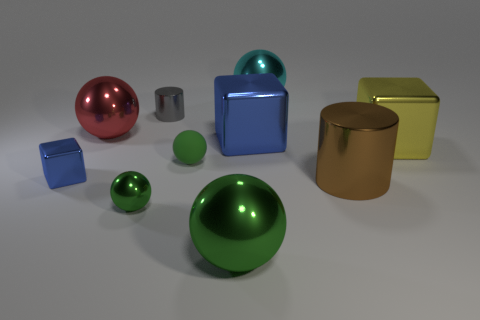How many things are either big cylinders that are right of the tiny metal block or balls?
Provide a succinct answer. 6. How many other things are the same size as the brown metal cylinder?
Ensure brevity in your answer.  5. There is a blue block that is to the right of the small shiny cube; what is its size?
Provide a succinct answer. Large. What is the shape of the big yellow object that is made of the same material as the large green thing?
Give a very brief answer. Cube. Are there any other things that have the same color as the small cube?
Offer a very short reply. Yes. The large shiny ball that is in front of the big metal sphere on the left side of the big green object is what color?
Offer a terse response. Green. What number of big objects are either objects or blue things?
Provide a short and direct response. 6. There is another tiny thing that is the same shape as the small green metallic thing; what material is it?
Your answer should be very brief. Rubber. Are there any other things that are made of the same material as the small blue block?
Provide a short and direct response. Yes. What is the color of the tiny shiny ball?
Provide a short and direct response. Green. 